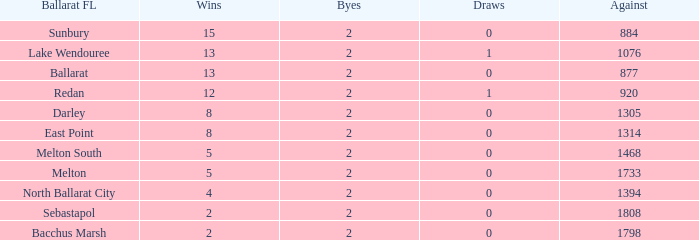How many Byes have Against of 1076 and Wins smaller than 13? None. 